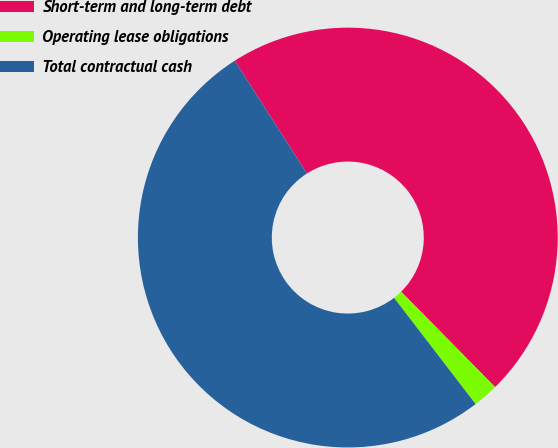Convert chart to OTSL. <chart><loc_0><loc_0><loc_500><loc_500><pie_chart><fcel>Short-term and long-term debt<fcel>Operating lease obligations<fcel>Total contractual cash<nl><fcel>46.67%<fcel>1.96%<fcel>51.37%<nl></chart> 